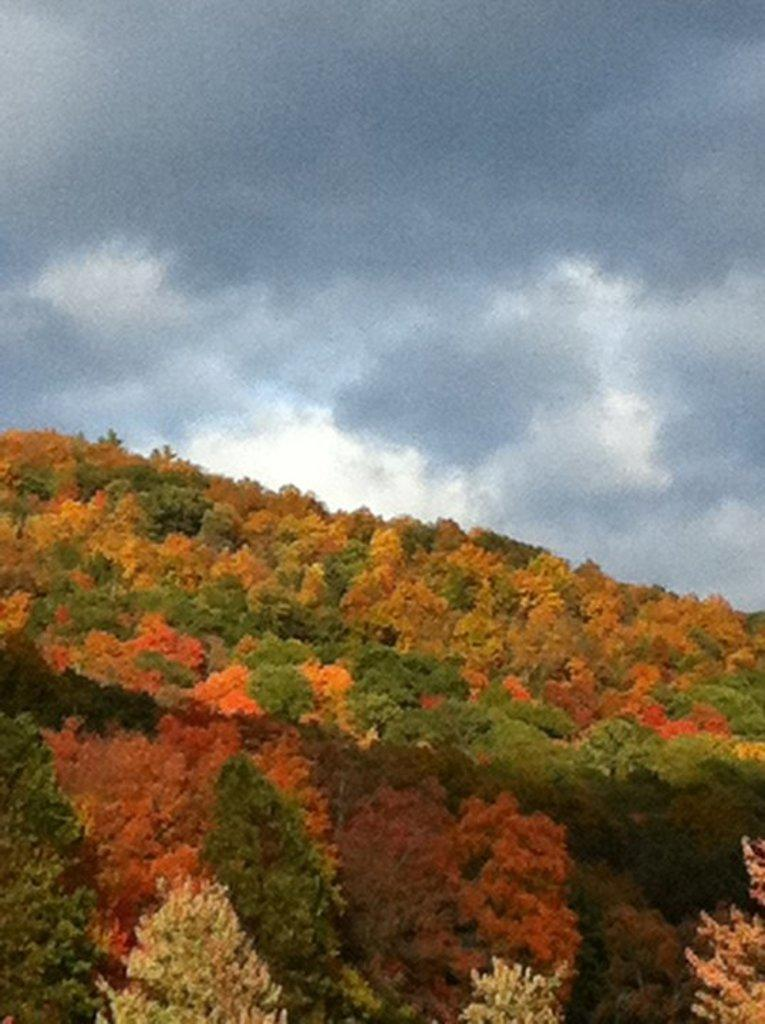What type of vegetation is present in the image? There are trees with leaves in the image. What colors can be seen on the leaves? The leaves are in green, red, and orange colors. What is visible in the background of the image? There is a cloudy sky in the background of the image. What type of lettuce is being used in the image? There is no lettuce present in the image; it features trees with leaves in various colors. 